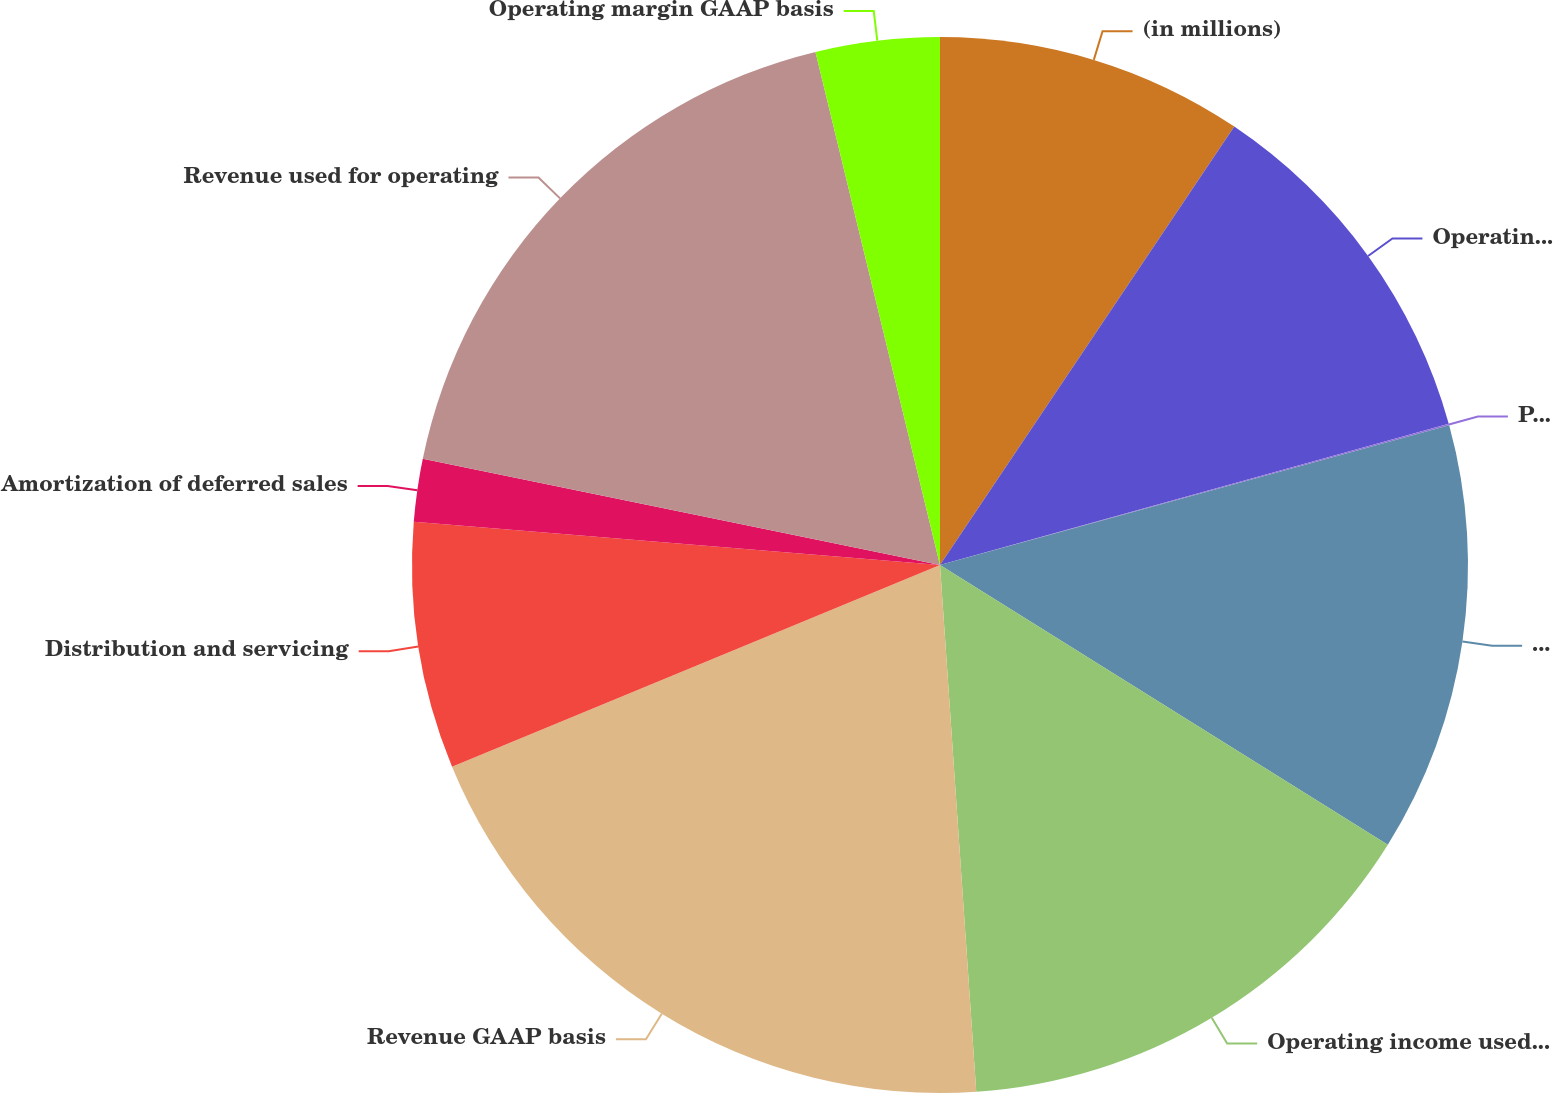<chart> <loc_0><loc_0><loc_500><loc_500><pie_chart><fcel>(in millions)<fcel>Operating income GAAP basis<fcel>PNC LTIP funding obligation<fcel>Operating income as adjusted<fcel>Operating income used for<fcel>Revenue GAAP basis<fcel>Distribution and servicing<fcel>Amortization of deferred sales<fcel>Revenue used for operating<fcel>Operating margin GAAP basis<nl><fcel>9.41%<fcel>11.28%<fcel>0.05%<fcel>13.15%<fcel>15.02%<fcel>19.86%<fcel>7.54%<fcel>1.92%<fcel>17.99%<fcel>3.79%<nl></chart> 